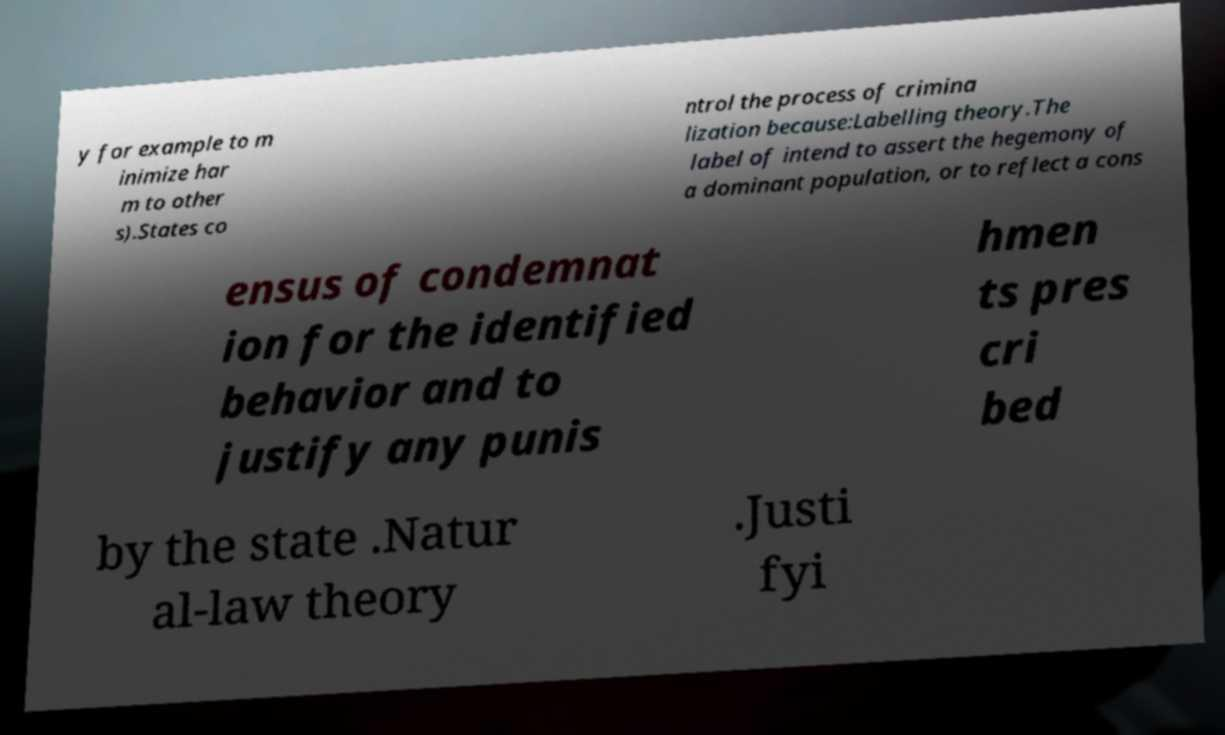There's text embedded in this image that I need extracted. Can you transcribe it verbatim? y for example to m inimize har m to other s).States co ntrol the process of crimina lization because:Labelling theory.The label of intend to assert the hegemony of a dominant population, or to reflect a cons ensus of condemnat ion for the identified behavior and to justify any punis hmen ts pres cri bed by the state .Natur al-law theory .Justi fyi 